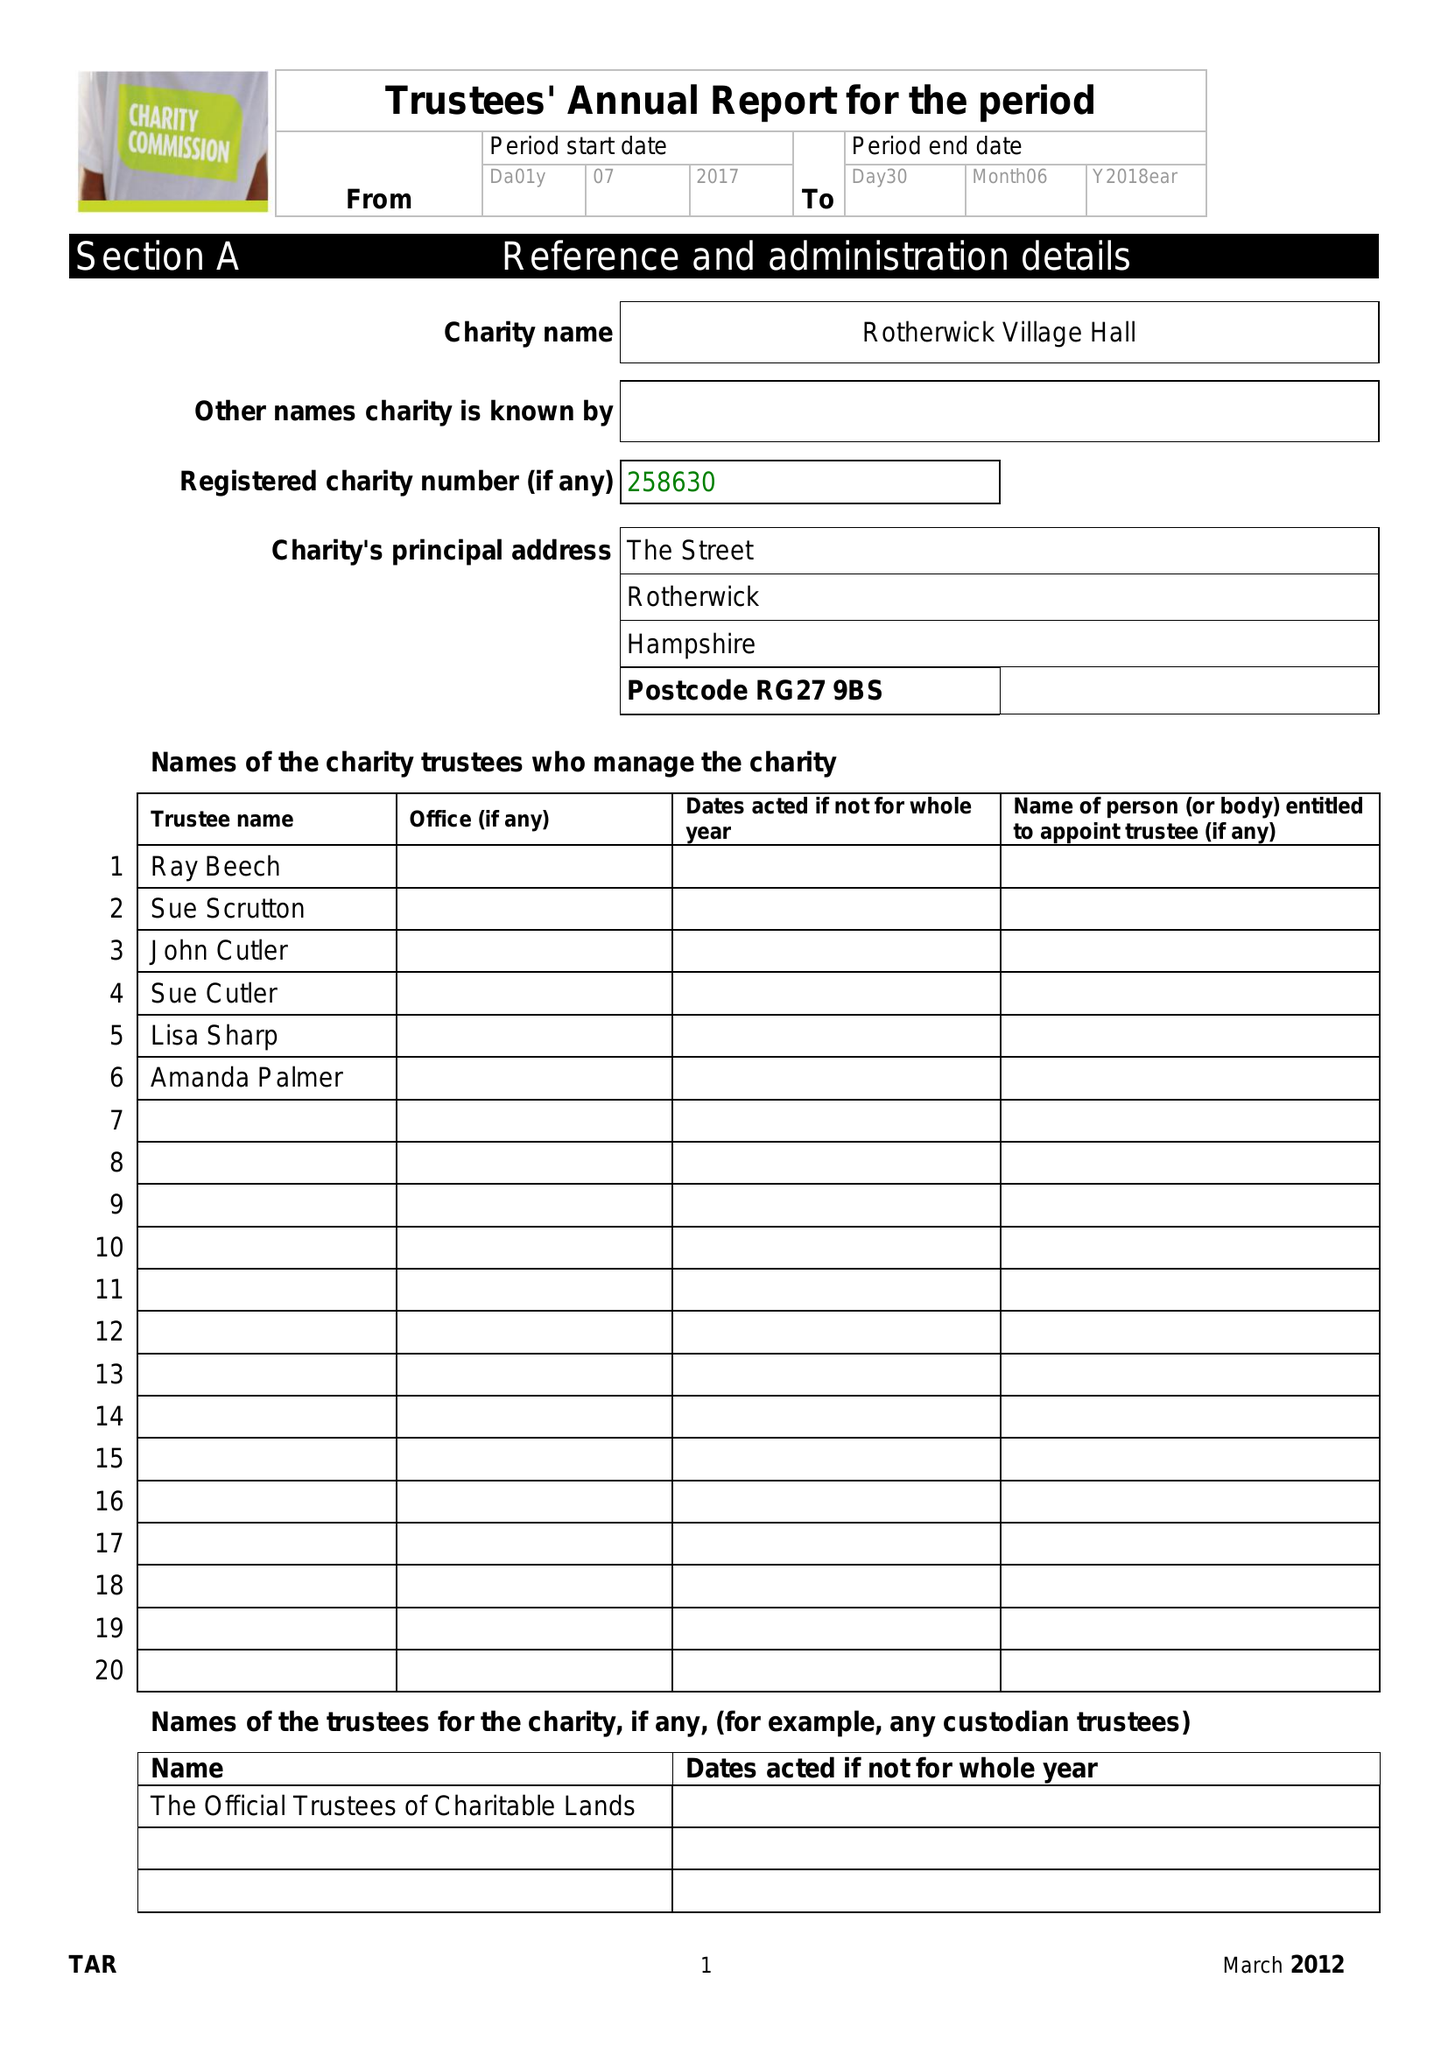What is the value for the address__street_line?
Answer the question using a single word or phrase. THE STREET 